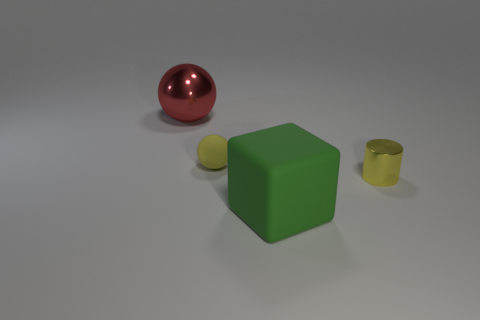Does the yellow object on the left side of the small shiny object have the same shape as the big object that is in front of the red sphere?
Your answer should be very brief. No. What number of other things are there of the same material as the cylinder
Your answer should be very brief. 1. The other tiny thing that is made of the same material as the red object is what shape?
Ensure brevity in your answer.  Cylinder. Do the yellow matte sphere and the red metallic sphere have the same size?
Your answer should be very brief. No. How big is the thing behind the rubber object that is behind the big block?
Offer a terse response. Large. There is a tiny thing that is the same color as the tiny shiny cylinder; what shape is it?
Ensure brevity in your answer.  Sphere. What number of cubes are either green things or rubber objects?
Provide a succinct answer. 1. There is a shiny ball; does it have the same size as the rubber object in front of the yellow matte ball?
Your answer should be very brief. Yes. Are there more green rubber cubes left of the tiny metallic cylinder than large gray spheres?
Provide a succinct answer. Yes. There is a red ball that is the same material as the small cylinder; what size is it?
Your answer should be compact. Large. 